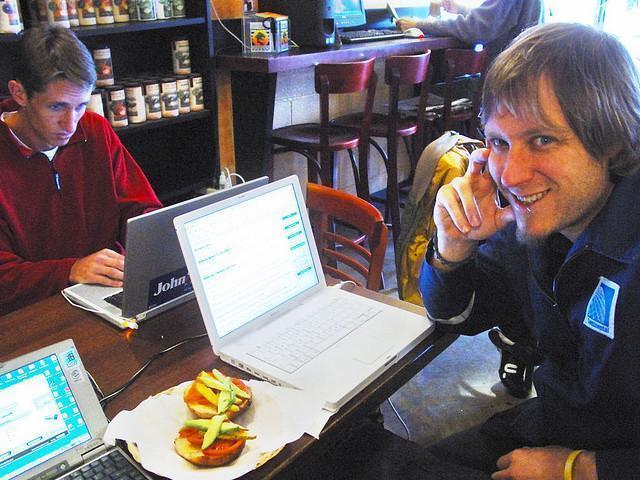What are the green items on top of the tomatoes on the man's sandwich?
Choose the correct response, then elucidate: 'Answer: answer
Rationale: rationale.'
Options: Relish, avocados, lettuce, pickles. Answer: avocados.
Rationale: The green parts are from that produce. 